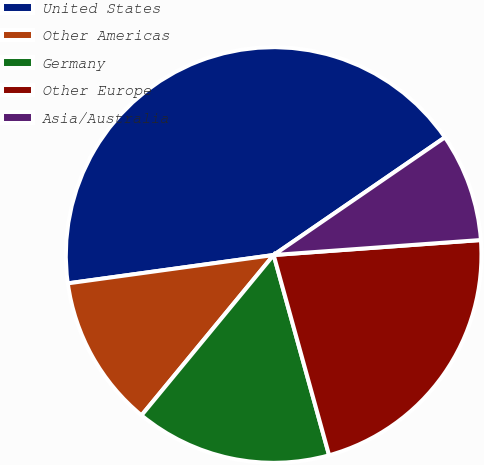Convert chart to OTSL. <chart><loc_0><loc_0><loc_500><loc_500><pie_chart><fcel>United States<fcel>Other Americas<fcel>Germany<fcel>Other Europe<fcel>Asia/Australia<nl><fcel>42.6%<fcel>11.85%<fcel>15.27%<fcel>21.85%<fcel>8.43%<nl></chart> 